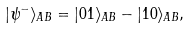Convert formula to latex. <formula><loc_0><loc_0><loc_500><loc_500>| \psi ^ { - } \rangle _ { A B } = | 0 1 \rangle _ { A B } - | 1 0 \rangle _ { A B } ,</formula> 